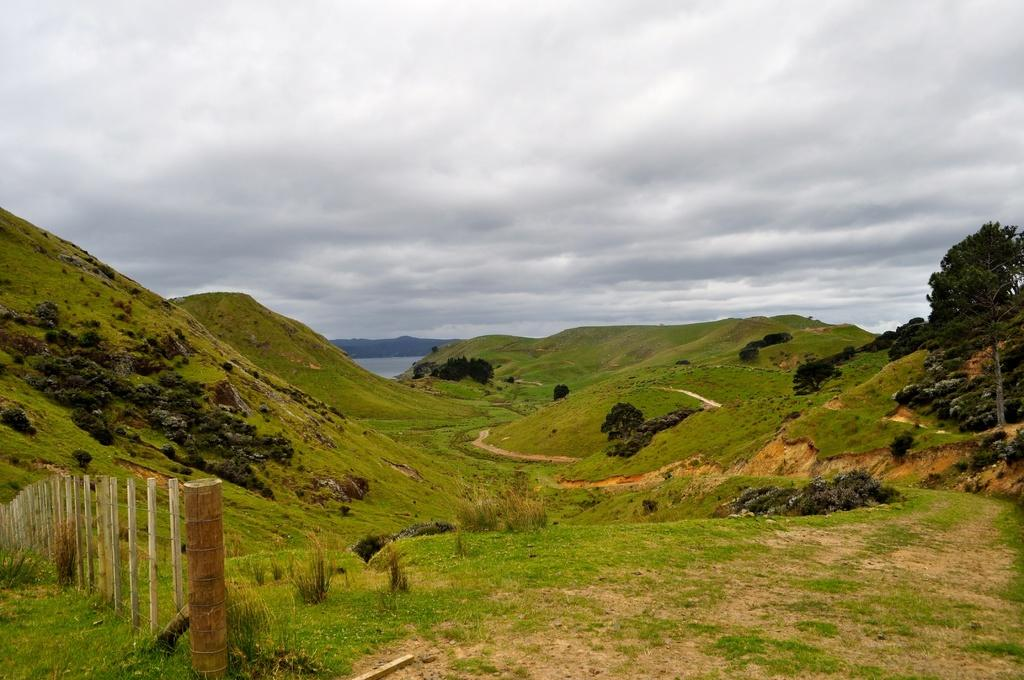What type of structure is located on the left side of the image? There is a fence on the left side of the image. What natural features can be seen in the middle of the image? There are hills in the middle of the image. What type of vegetation is on the right side of the image? There are trees on the right side of the image. What is visible at the top of the image? The sky is visible at the top of the image. What season is depicted in the image, considering the presence of winter elements? There is no indication of a specific season in the image, as it features a fence, hills, trees, and the sky, which are not exclusive to any particular season. 